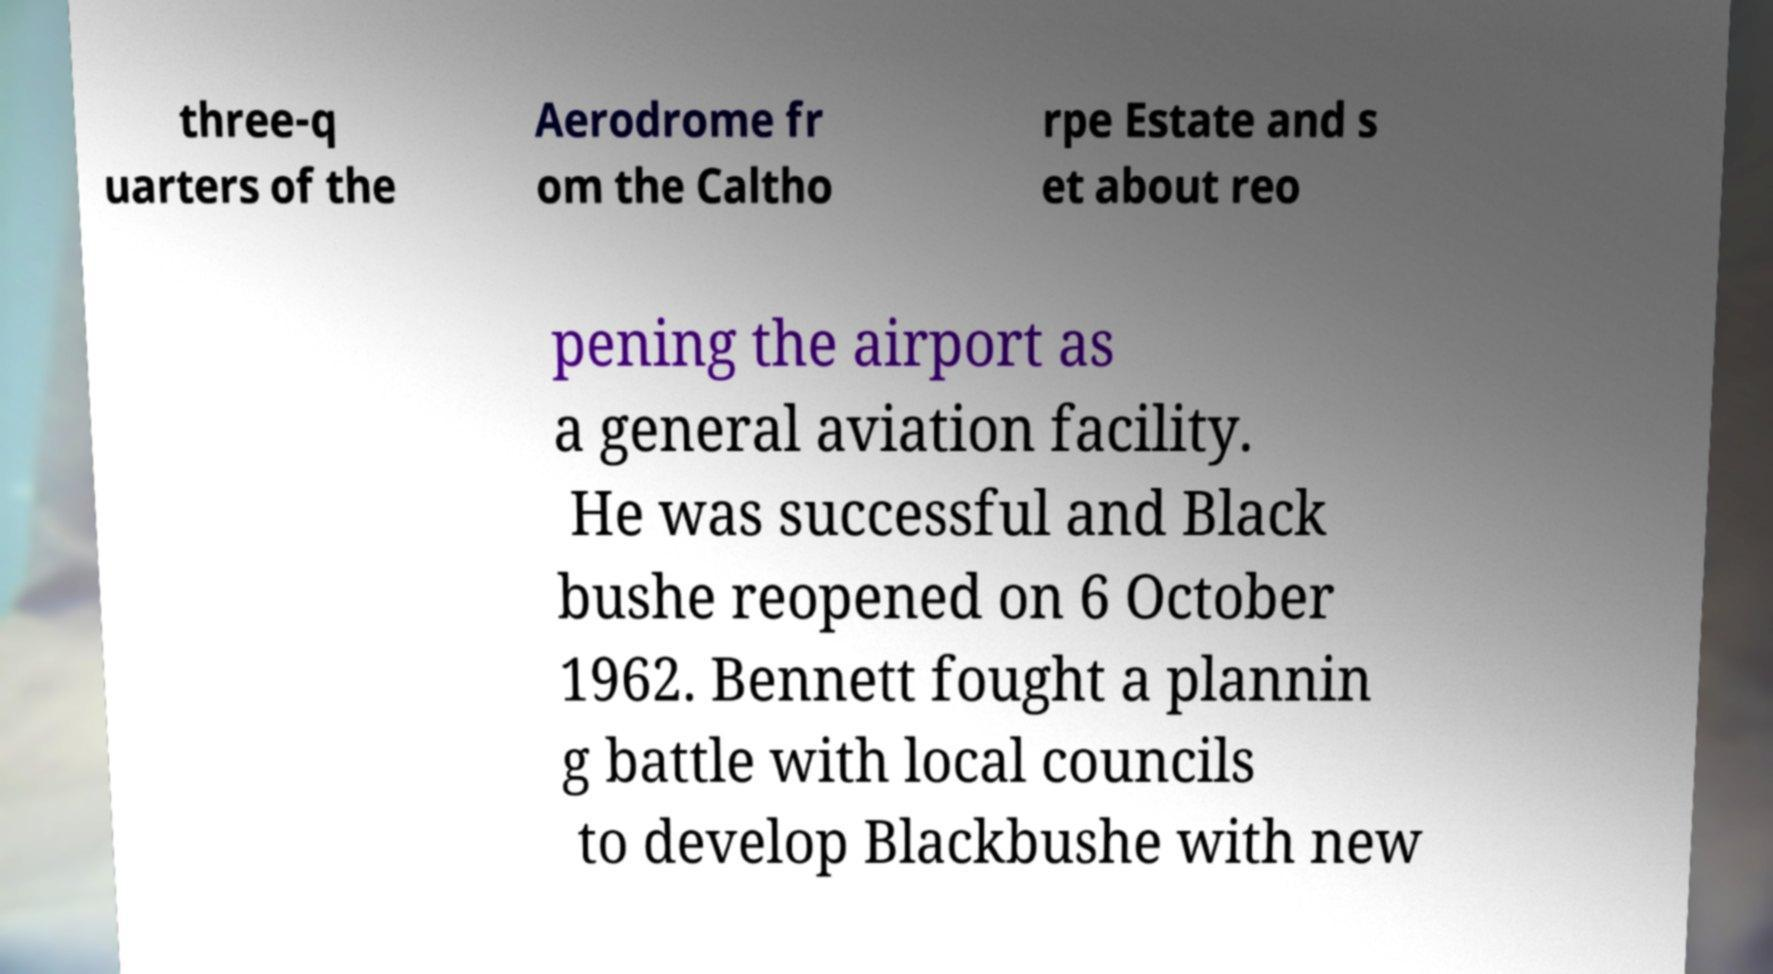Could you extract and type out the text from this image? three-q uarters of the Aerodrome fr om the Caltho rpe Estate and s et about reo pening the airport as a general aviation facility. He was successful and Black bushe reopened on 6 October 1962. Bennett fought a plannin g battle with local councils to develop Blackbushe with new 